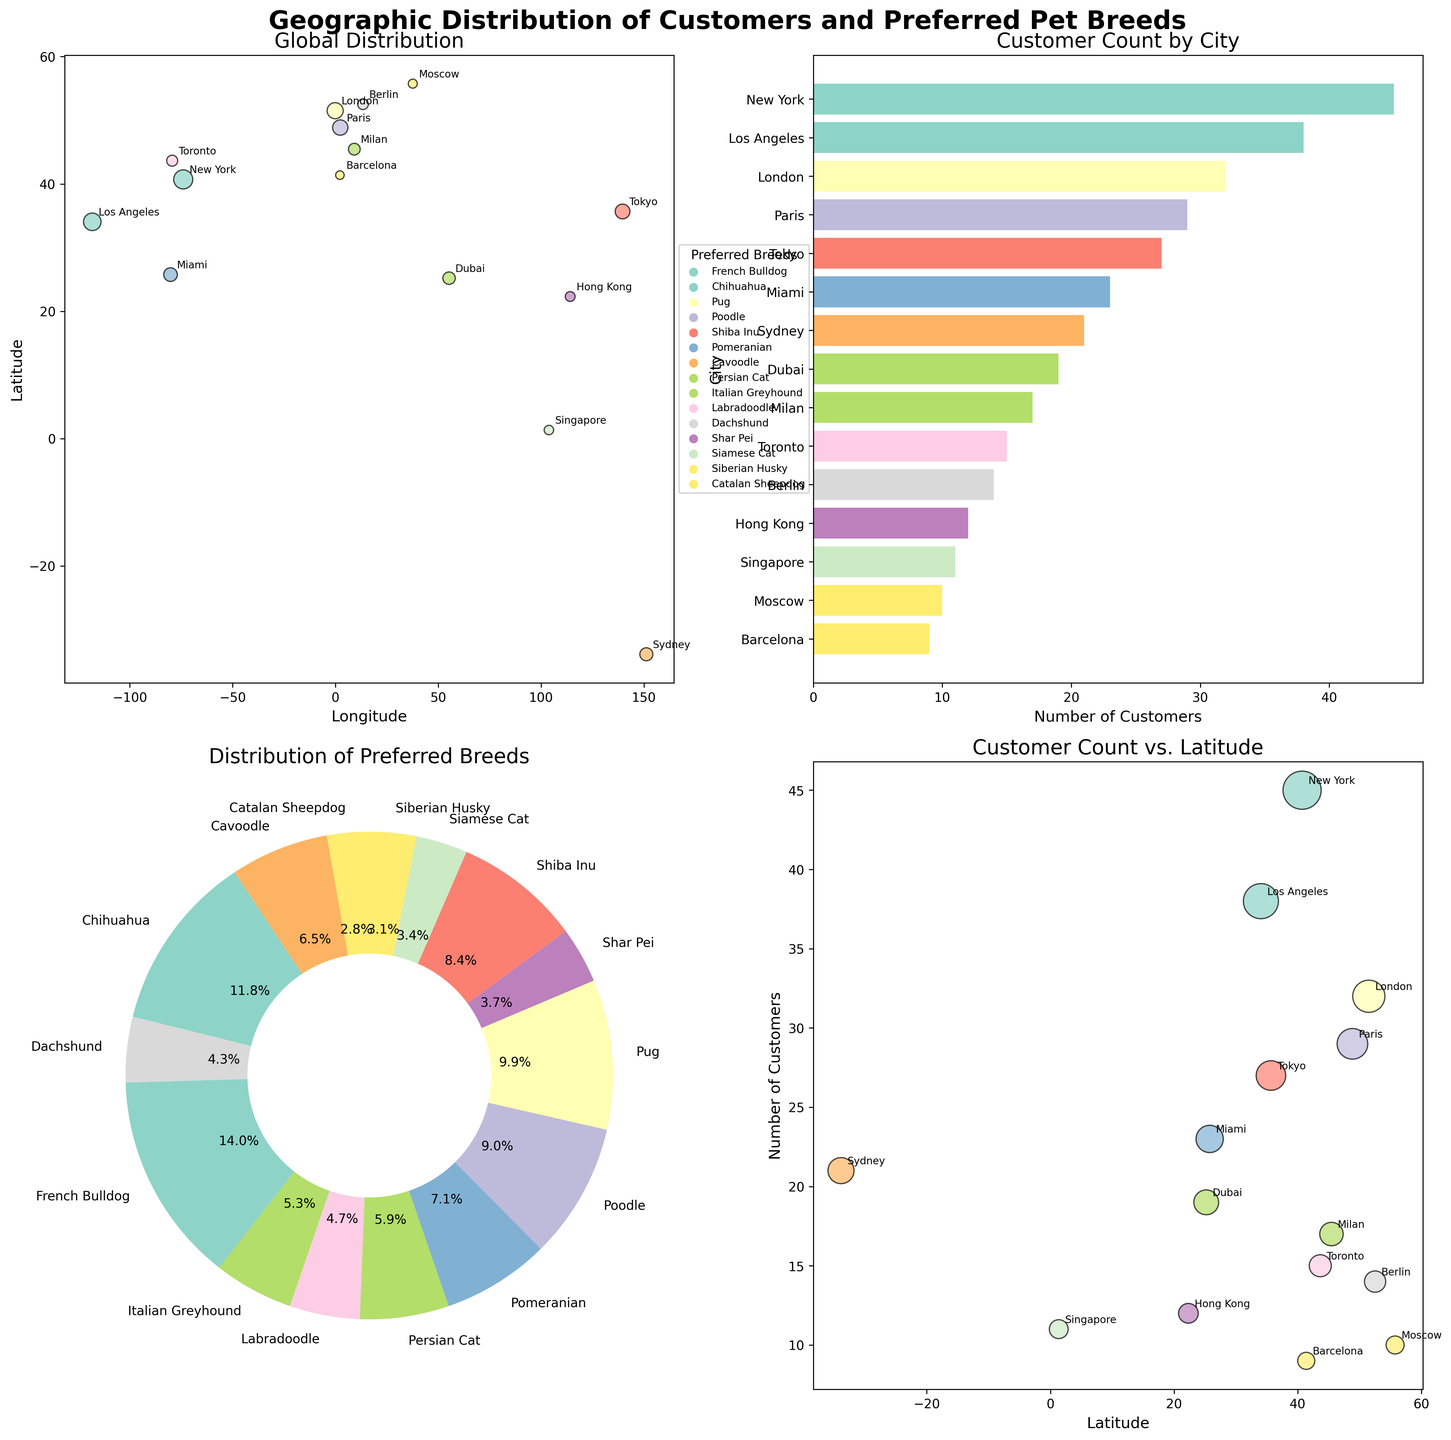What cities are represented in the Global Distribution scatter plot? In the Global Distribution scatter plot, 15 cities are represented with labels indicating their names, such as New York, London, Tokyo, and Paris. Each city is marked with a scatter point.
Answer: 15 cities Which city has the highest customer count? In the Customer Count by City bar plot, New York has the highest bar among all cities, indicating the highest customer count.
Answer: New York What is the most preferred pet breed globally? In the Distribution of Preferred Breeds pie chart, French Bulldog has the largest slice, indicating it is the most preferred breed among the customers.
Answer: French Bulldog What is the relationship between latitude and customer count in the Customer Count vs. Latitude scatter plot? The scatter plot of Customer Count vs. Latitude shows that cities with latitudes between 40 and 50 degrees tend to have higher customer counts. New York and London are good examples.
Answer: Higher customer counts around 40 to 50 degrees latitude How is the color coding of data points determined in the scatter plots? The color coding in the scatter plots is based on the preferred pet breeds of the customers. Each breed is assigned a unique color. This can be confirmed by looking at the legend in the Global Distribution scatter plot.
Answer: By preferred pet breeds Which city has the lowest customer count, and what is their preferred breed? In the Customer Count by City bar plot, Barcelona has the lowest bar, indicating the lowest customer count. The preferred breed in Barcelona is Catalan Sheepdog.
Answer: Barcelona, Catalan Sheepdog How are cities geographically distributed in the Global Distribution scatter plot? In the Global Distribution scatter plot, cities are geographically distributed across the world, with markers spread across different longitudes and latitudes, showing a global presence from cities in Europe, North America, Asia, etc.
Answer: Geographically distributed across the world Which pet breeds are preferred by customers in the Southern Hemisphere? In the Global Distribution scatter plot, Sydney is in the Southern Hemisphere, with Cavoodle as the preferred breed of customers there.
Answer: Cavoodle What percentage of customers prefer breeds of dogs over cats? In the Distribution of Preferred Breeds pie chart, most of the slices are for dog breeds, with only Persian Cat and Siamese Cat for cat breeds. Summing up the percentages for dogs and subtracting from 100% can answer this. For example, dogs take about 86.7% (100% - 13.3% for cats).
Answer: 86.7% Compare the customer counts between Milan and Toronto. In both the Customer Count by City bar plot and Global Distribution scatter plot, Milan has 17 customers, and Toronto has 15. Thus, Milan has slightly more customers than Toronto.
Answer: Milan has 2 more customers than Toronto 